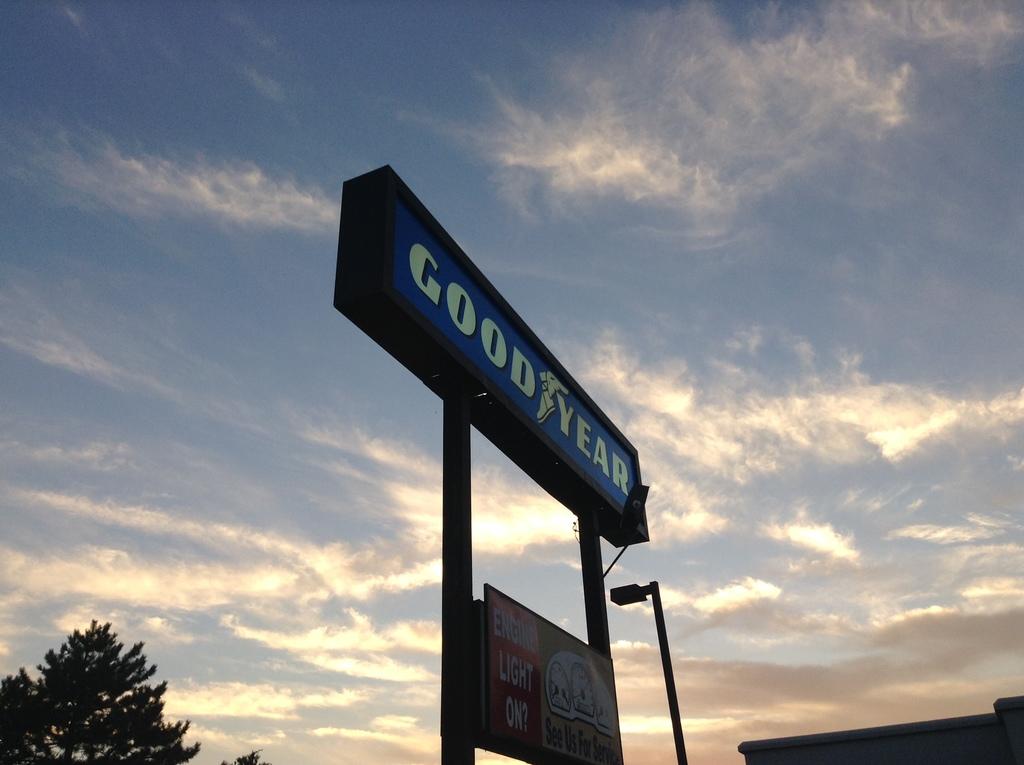What is the company advertised on the blue sign?
Keep it short and to the point. Goodyear. What light are they asking is on, on the bottom sign?
Your response must be concise. Engine. 